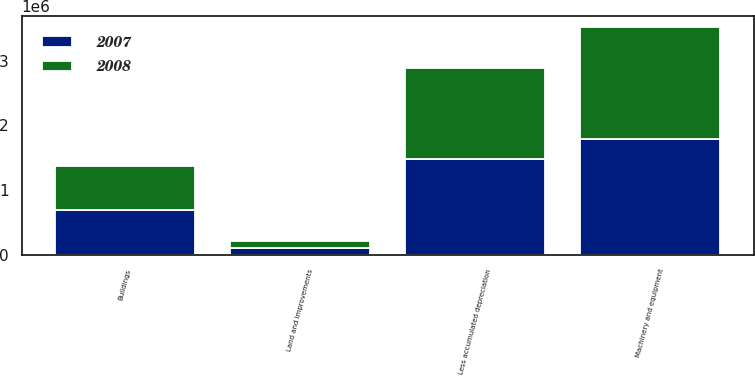Convert chart to OTSL. <chart><loc_0><loc_0><loc_500><loc_500><stacked_bar_chart><ecel><fcel>Land and improvements<fcel>Buildings<fcel>Machinery and equipment<fcel>Less accumulated depreciation<nl><fcel>2007<fcel>106472<fcel>691766<fcel>1.79362e+06<fcel>1.4832e+06<nl><fcel>2008<fcel>105096<fcel>679575<fcel>1.72643e+06<fcel>1.40246e+06<nl></chart> 